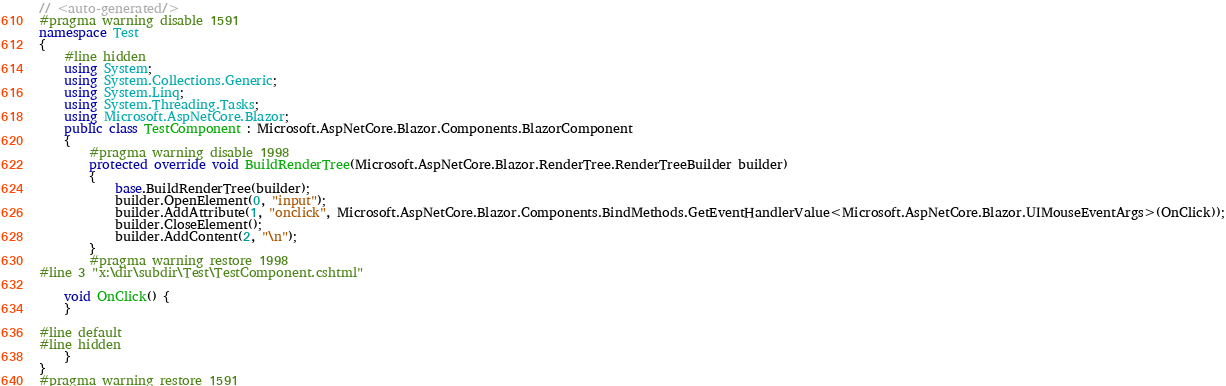Convert code to text. <code><loc_0><loc_0><loc_500><loc_500><_C#_>// <auto-generated/>
#pragma warning disable 1591
namespace Test
{
    #line hidden
    using System;
    using System.Collections.Generic;
    using System.Linq;
    using System.Threading.Tasks;
    using Microsoft.AspNetCore.Blazor;
    public class TestComponent : Microsoft.AspNetCore.Blazor.Components.BlazorComponent
    {
        #pragma warning disable 1998
        protected override void BuildRenderTree(Microsoft.AspNetCore.Blazor.RenderTree.RenderTreeBuilder builder)
        {
            base.BuildRenderTree(builder);
            builder.OpenElement(0, "input");
            builder.AddAttribute(1, "onclick", Microsoft.AspNetCore.Blazor.Components.BindMethods.GetEventHandlerValue<Microsoft.AspNetCore.Blazor.UIMouseEventArgs>(OnClick));
            builder.CloseElement();
            builder.AddContent(2, "\n");
        }
        #pragma warning restore 1998
#line 3 "x:\dir\subdir\Test\TestComponent.cshtml"
            
    void OnClick() {
    }

#line default
#line hidden
    }
}
#pragma warning restore 1591
</code> 